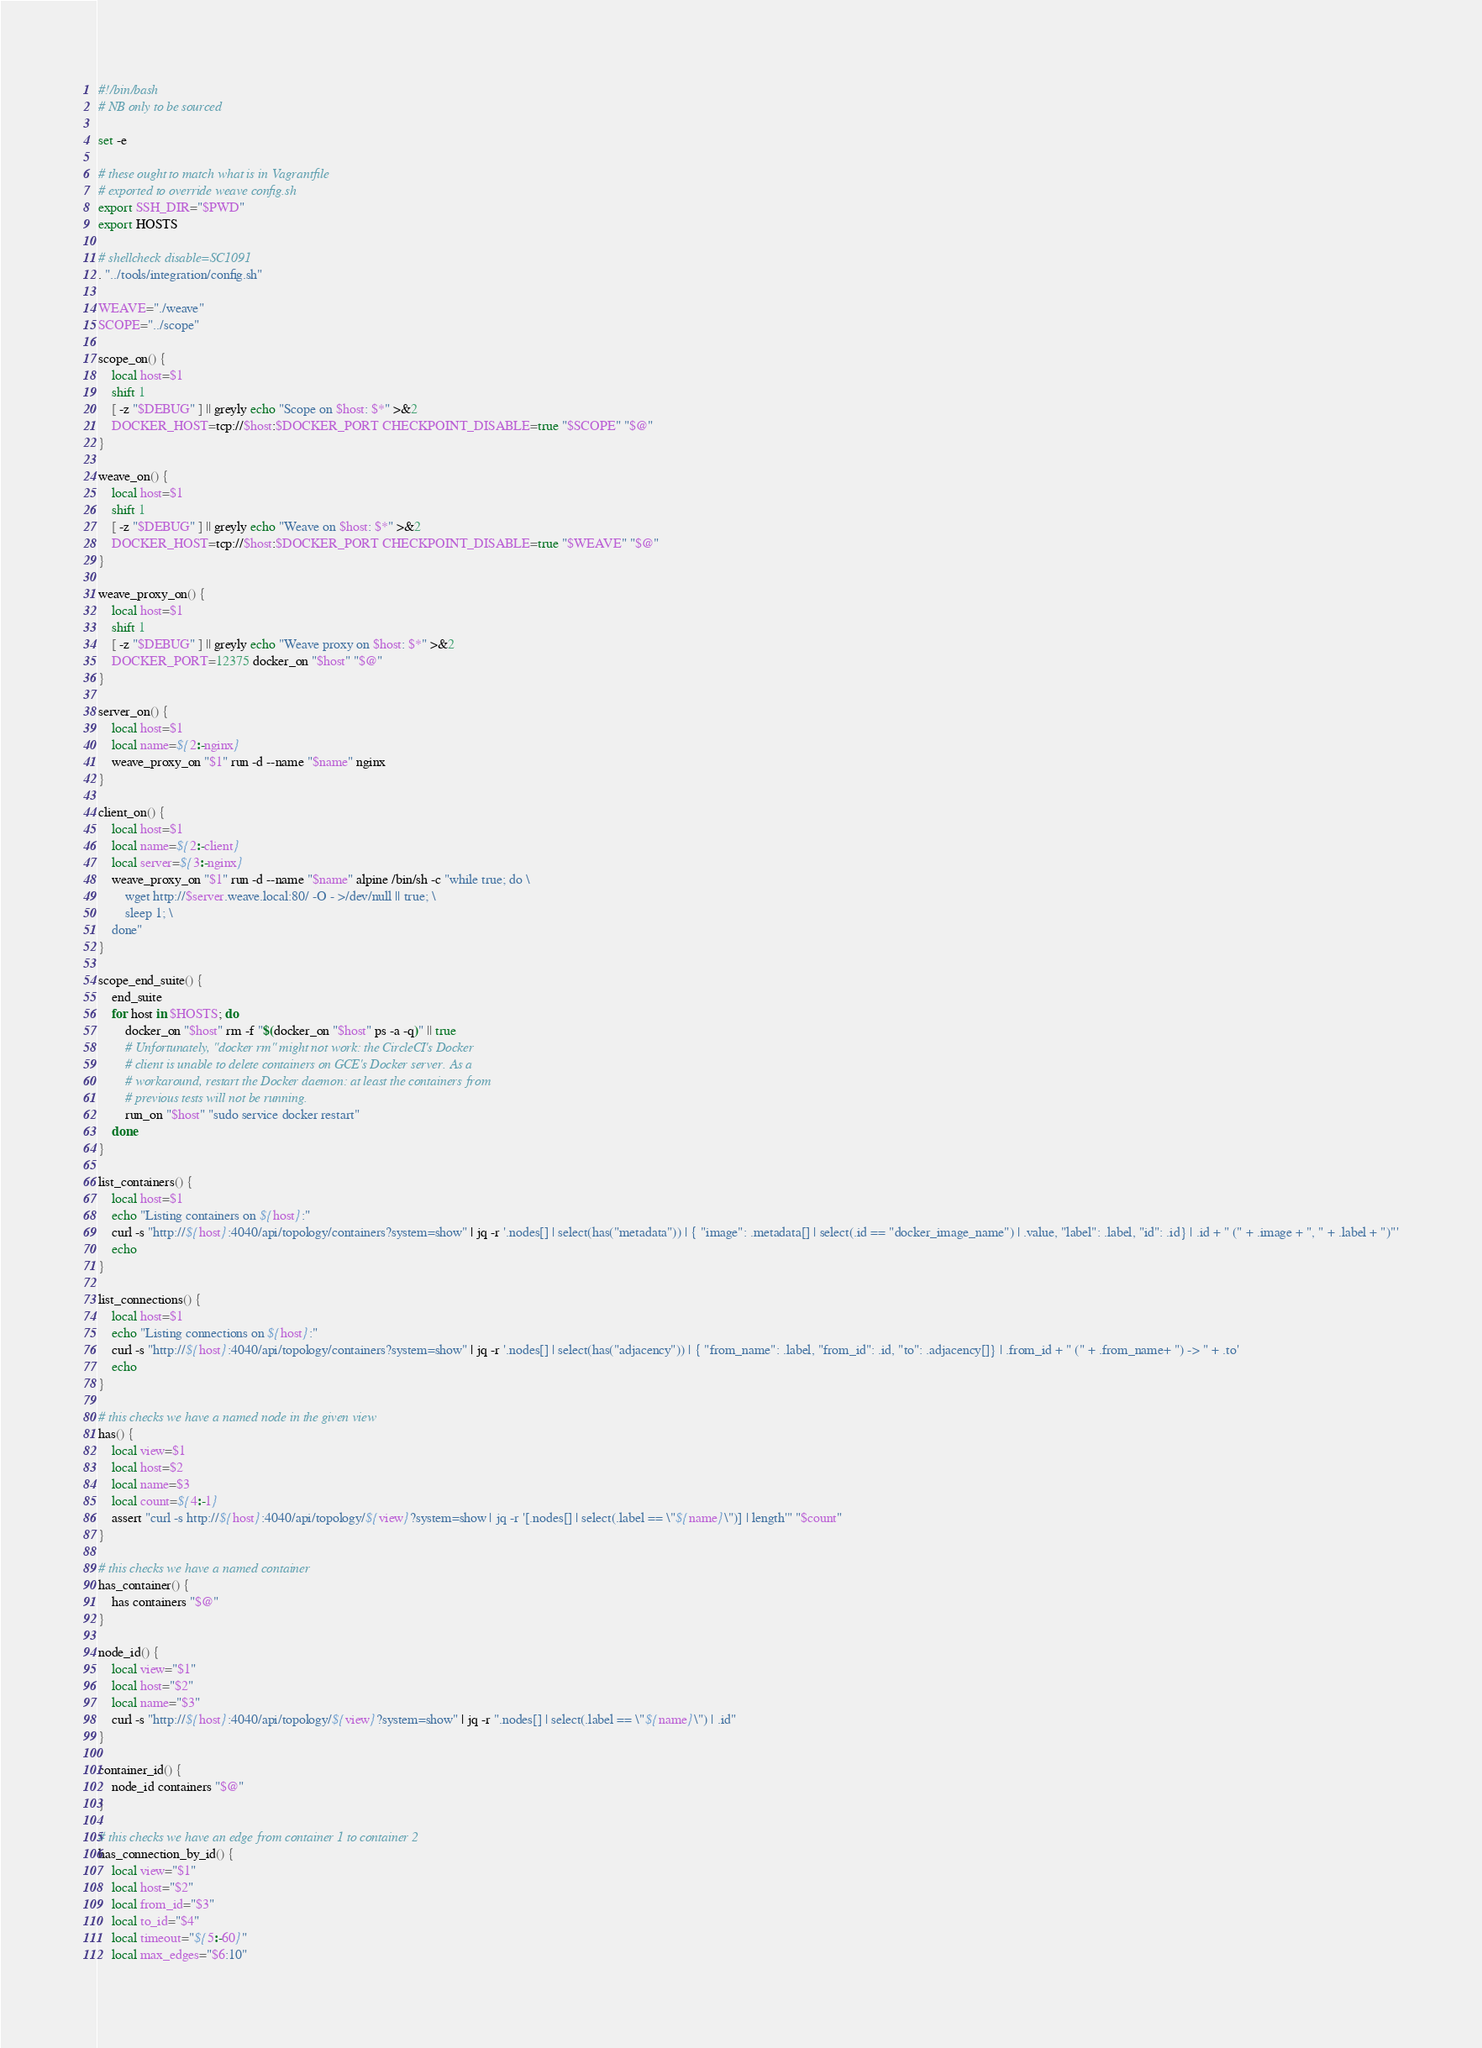<code> <loc_0><loc_0><loc_500><loc_500><_Bash_>#!/bin/bash
# NB only to be sourced

set -e

# these ought to match what is in Vagrantfile
# exported to override weave config.sh
export SSH_DIR="$PWD"
export HOSTS

# shellcheck disable=SC1091
. "../tools/integration/config.sh"

WEAVE="./weave"
SCOPE="../scope"

scope_on() {
    local host=$1
    shift 1
    [ -z "$DEBUG" ] || greyly echo "Scope on $host: $*" >&2
    DOCKER_HOST=tcp://$host:$DOCKER_PORT CHECKPOINT_DISABLE=true "$SCOPE" "$@"
}

weave_on() {
    local host=$1
    shift 1
    [ -z "$DEBUG" ] || greyly echo "Weave on $host: $*" >&2
    DOCKER_HOST=tcp://$host:$DOCKER_PORT CHECKPOINT_DISABLE=true "$WEAVE" "$@"
}

weave_proxy_on() {
    local host=$1
    shift 1
    [ -z "$DEBUG" ] || greyly echo "Weave proxy on $host: $*" >&2
    DOCKER_PORT=12375 docker_on "$host" "$@"
}

server_on() {
    local host=$1
    local name=${2:-nginx}
    weave_proxy_on "$1" run -d --name "$name" nginx
}

client_on() {
    local host=$1
    local name=${2:-client}
    local server=${3:-nginx}
    weave_proxy_on "$1" run -d --name "$name" alpine /bin/sh -c "while true; do \
        wget http://$server.weave.local:80/ -O - >/dev/null || true; \
        sleep 1; \
    done"
}

scope_end_suite() {
    end_suite
    for host in $HOSTS; do
        docker_on "$host" rm -f "$(docker_on "$host" ps -a -q)" || true
        # Unfortunately, "docker rm" might not work: the CircleCI's Docker
        # client is unable to delete containers on GCE's Docker server. As a
        # workaround, restart the Docker daemon: at least the containers from
        # previous tests will not be running.
        run_on "$host" "sudo service docker restart"
    done
}

list_containers() {
    local host=$1
    echo "Listing containers on ${host}:"
    curl -s "http://${host}:4040/api/topology/containers?system=show" | jq -r '.nodes[] | select(has("metadata")) | { "image": .metadata[] | select(.id == "docker_image_name") | .value, "label": .label, "id": .id} | .id + " (" + .image + ", " + .label + ")"'
    echo
}

list_connections() {
    local host=$1
    echo "Listing connections on ${host}:"
    curl -s "http://${host}:4040/api/topology/containers?system=show" | jq -r '.nodes[] | select(has("adjacency")) | { "from_name": .label, "from_id": .id, "to": .adjacency[]} | .from_id + " (" + .from_name+ ") -> " + .to'
    echo
}

# this checks we have a named node in the given view
has() {
    local view=$1
    local host=$2
    local name=$3
    local count=${4:-1}
    assert "curl -s http://${host}:4040/api/topology/${view}?system=show | jq -r '[.nodes[] | select(.label == \"${name}\")] | length'" "$count"
}

# this checks we have a named container
has_container() {
    has containers "$@"
}

node_id() {
    local view="$1"
    local host="$2"
    local name="$3"
    curl -s "http://${host}:4040/api/topology/${view}?system=show" | jq -r ".nodes[] | select(.label == \"${name}\") | .id"
}

container_id() {
    node_id containers "$@"
}

# this checks we have an edge from container 1 to container 2
has_connection_by_id() {
    local view="$1"
    local host="$2"
    local from_id="$3"
    local to_id="$4"
    local timeout="${5:-60}"
    local max_edges="$6:10"
</code> 